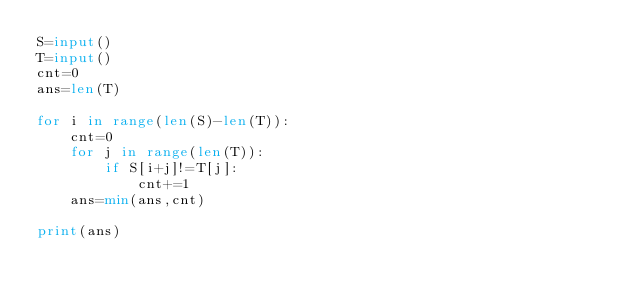Convert code to text. <code><loc_0><loc_0><loc_500><loc_500><_Python_>S=input()
T=input()
cnt=0
ans=len(T)

for i in range(len(S)-len(T)):
    cnt=0
    for j in range(len(T)):
        if S[i+j]!=T[j]:
            cnt+=1
    ans=min(ans,cnt)
        
print(ans)</code> 